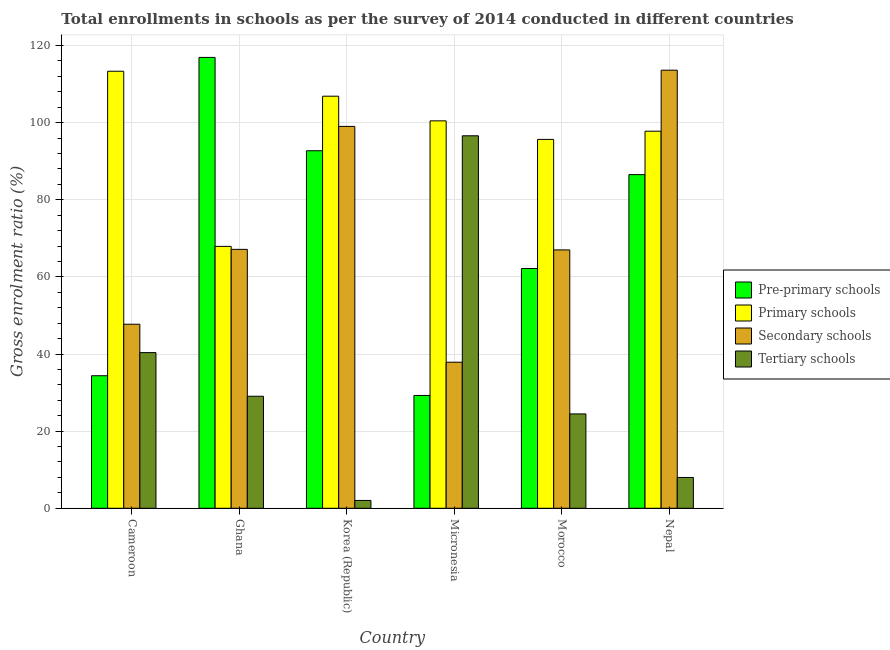How many different coloured bars are there?
Give a very brief answer. 4. Are the number of bars on each tick of the X-axis equal?
Give a very brief answer. Yes. What is the label of the 1st group of bars from the left?
Make the answer very short. Cameroon. In how many cases, is the number of bars for a given country not equal to the number of legend labels?
Keep it short and to the point. 0. What is the gross enrolment ratio in secondary schools in Ghana?
Make the answer very short. 67.13. Across all countries, what is the maximum gross enrolment ratio in tertiary schools?
Provide a short and direct response. 96.58. Across all countries, what is the minimum gross enrolment ratio in secondary schools?
Make the answer very short. 37.87. In which country was the gross enrolment ratio in secondary schools maximum?
Keep it short and to the point. Nepal. What is the total gross enrolment ratio in tertiary schools in the graph?
Provide a succinct answer. 200.48. What is the difference between the gross enrolment ratio in secondary schools in Cameroon and that in Morocco?
Your response must be concise. -19.27. What is the difference between the gross enrolment ratio in primary schools in Cameroon and the gross enrolment ratio in pre-primary schools in Morocco?
Your answer should be compact. 51.15. What is the average gross enrolment ratio in secondary schools per country?
Keep it short and to the point. 72.06. What is the difference between the gross enrolment ratio in secondary schools and gross enrolment ratio in tertiary schools in Micronesia?
Offer a very short reply. -58.71. In how many countries, is the gross enrolment ratio in tertiary schools greater than 116 %?
Give a very brief answer. 0. What is the ratio of the gross enrolment ratio in tertiary schools in Cameroon to that in Ghana?
Make the answer very short. 1.39. What is the difference between the highest and the second highest gross enrolment ratio in pre-primary schools?
Offer a terse response. 24.2. What is the difference between the highest and the lowest gross enrolment ratio in primary schools?
Your response must be concise. 45.42. In how many countries, is the gross enrolment ratio in primary schools greater than the average gross enrolment ratio in primary schools taken over all countries?
Make the answer very short. 4. Is the sum of the gross enrolment ratio in secondary schools in Micronesia and Nepal greater than the maximum gross enrolment ratio in pre-primary schools across all countries?
Provide a short and direct response. Yes. Is it the case that in every country, the sum of the gross enrolment ratio in pre-primary schools and gross enrolment ratio in primary schools is greater than the sum of gross enrolment ratio in secondary schools and gross enrolment ratio in tertiary schools?
Make the answer very short. No. What does the 4th bar from the left in Morocco represents?
Your answer should be very brief. Tertiary schools. What does the 4th bar from the right in Cameroon represents?
Provide a succinct answer. Pre-primary schools. What is the difference between two consecutive major ticks on the Y-axis?
Provide a short and direct response. 20. Does the graph contain any zero values?
Offer a very short reply. No. What is the title of the graph?
Keep it short and to the point. Total enrollments in schools as per the survey of 2014 conducted in different countries. What is the label or title of the X-axis?
Ensure brevity in your answer.  Country. What is the label or title of the Y-axis?
Offer a very short reply. Gross enrolment ratio (%). What is the Gross enrolment ratio (%) of Pre-primary schools in Cameroon?
Provide a succinct answer. 34.37. What is the Gross enrolment ratio (%) in Primary schools in Cameroon?
Make the answer very short. 113.32. What is the Gross enrolment ratio (%) in Secondary schools in Cameroon?
Give a very brief answer. 47.72. What is the Gross enrolment ratio (%) of Tertiary schools in Cameroon?
Make the answer very short. 40.36. What is the Gross enrolment ratio (%) of Pre-primary schools in Ghana?
Provide a short and direct response. 116.91. What is the Gross enrolment ratio (%) in Primary schools in Ghana?
Your response must be concise. 67.91. What is the Gross enrolment ratio (%) in Secondary schools in Ghana?
Provide a succinct answer. 67.13. What is the Gross enrolment ratio (%) of Tertiary schools in Ghana?
Provide a succinct answer. 29.05. What is the Gross enrolment ratio (%) of Pre-primary schools in Korea (Republic)?
Provide a short and direct response. 92.71. What is the Gross enrolment ratio (%) in Primary schools in Korea (Republic)?
Ensure brevity in your answer.  106.85. What is the Gross enrolment ratio (%) in Secondary schools in Korea (Republic)?
Provide a short and direct response. 99.02. What is the Gross enrolment ratio (%) in Tertiary schools in Korea (Republic)?
Provide a succinct answer. 2.03. What is the Gross enrolment ratio (%) of Pre-primary schools in Micronesia?
Keep it short and to the point. 29.25. What is the Gross enrolment ratio (%) of Primary schools in Micronesia?
Keep it short and to the point. 100.46. What is the Gross enrolment ratio (%) in Secondary schools in Micronesia?
Give a very brief answer. 37.87. What is the Gross enrolment ratio (%) of Tertiary schools in Micronesia?
Provide a succinct answer. 96.58. What is the Gross enrolment ratio (%) in Pre-primary schools in Morocco?
Make the answer very short. 62.17. What is the Gross enrolment ratio (%) of Primary schools in Morocco?
Offer a very short reply. 95.65. What is the Gross enrolment ratio (%) of Secondary schools in Morocco?
Give a very brief answer. 66.99. What is the Gross enrolment ratio (%) in Tertiary schools in Morocco?
Offer a very short reply. 24.47. What is the Gross enrolment ratio (%) in Pre-primary schools in Nepal?
Ensure brevity in your answer.  86.52. What is the Gross enrolment ratio (%) of Primary schools in Nepal?
Provide a succinct answer. 97.77. What is the Gross enrolment ratio (%) of Secondary schools in Nepal?
Keep it short and to the point. 113.6. What is the Gross enrolment ratio (%) in Tertiary schools in Nepal?
Provide a succinct answer. 7.99. Across all countries, what is the maximum Gross enrolment ratio (%) of Pre-primary schools?
Keep it short and to the point. 116.91. Across all countries, what is the maximum Gross enrolment ratio (%) in Primary schools?
Make the answer very short. 113.32. Across all countries, what is the maximum Gross enrolment ratio (%) in Secondary schools?
Keep it short and to the point. 113.6. Across all countries, what is the maximum Gross enrolment ratio (%) of Tertiary schools?
Keep it short and to the point. 96.58. Across all countries, what is the minimum Gross enrolment ratio (%) of Pre-primary schools?
Give a very brief answer. 29.25. Across all countries, what is the minimum Gross enrolment ratio (%) in Primary schools?
Offer a very short reply. 67.91. Across all countries, what is the minimum Gross enrolment ratio (%) in Secondary schools?
Ensure brevity in your answer.  37.87. Across all countries, what is the minimum Gross enrolment ratio (%) in Tertiary schools?
Provide a short and direct response. 2.03. What is the total Gross enrolment ratio (%) of Pre-primary schools in the graph?
Provide a short and direct response. 421.93. What is the total Gross enrolment ratio (%) in Primary schools in the graph?
Offer a terse response. 581.96. What is the total Gross enrolment ratio (%) in Secondary schools in the graph?
Offer a very short reply. 432.34. What is the total Gross enrolment ratio (%) in Tertiary schools in the graph?
Your answer should be compact. 200.48. What is the difference between the Gross enrolment ratio (%) of Pre-primary schools in Cameroon and that in Ghana?
Keep it short and to the point. -82.54. What is the difference between the Gross enrolment ratio (%) in Primary schools in Cameroon and that in Ghana?
Make the answer very short. 45.42. What is the difference between the Gross enrolment ratio (%) of Secondary schools in Cameroon and that in Ghana?
Provide a succinct answer. -19.41. What is the difference between the Gross enrolment ratio (%) of Tertiary schools in Cameroon and that in Ghana?
Your answer should be very brief. 11.32. What is the difference between the Gross enrolment ratio (%) of Pre-primary schools in Cameroon and that in Korea (Republic)?
Ensure brevity in your answer.  -58.34. What is the difference between the Gross enrolment ratio (%) of Primary schools in Cameroon and that in Korea (Republic)?
Give a very brief answer. 6.47. What is the difference between the Gross enrolment ratio (%) of Secondary schools in Cameroon and that in Korea (Republic)?
Give a very brief answer. -51.3. What is the difference between the Gross enrolment ratio (%) in Tertiary schools in Cameroon and that in Korea (Republic)?
Offer a very short reply. 38.33. What is the difference between the Gross enrolment ratio (%) in Pre-primary schools in Cameroon and that in Micronesia?
Offer a terse response. 5.12. What is the difference between the Gross enrolment ratio (%) of Primary schools in Cameroon and that in Micronesia?
Your answer should be compact. 12.87. What is the difference between the Gross enrolment ratio (%) of Secondary schools in Cameroon and that in Micronesia?
Keep it short and to the point. 9.85. What is the difference between the Gross enrolment ratio (%) in Tertiary schools in Cameroon and that in Micronesia?
Provide a short and direct response. -56.22. What is the difference between the Gross enrolment ratio (%) of Pre-primary schools in Cameroon and that in Morocco?
Ensure brevity in your answer.  -27.8. What is the difference between the Gross enrolment ratio (%) in Primary schools in Cameroon and that in Morocco?
Make the answer very short. 17.67. What is the difference between the Gross enrolment ratio (%) of Secondary schools in Cameroon and that in Morocco?
Offer a very short reply. -19.27. What is the difference between the Gross enrolment ratio (%) of Tertiary schools in Cameroon and that in Morocco?
Your answer should be compact. 15.89. What is the difference between the Gross enrolment ratio (%) of Pre-primary schools in Cameroon and that in Nepal?
Your answer should be compact. -52.15. What is the difference between the Gross enrolment ratio (%) of Primary schools in Cameroon and that in Nepal?
Offer a terse response. 15.55. What is the difference between the Gross enrolment ratio (%) of Secondary schools in Cameroon and that in Nepal?
Your response must be concise. -65.88. What is the difference between the Gross enrolment ratio (%) of Tertiary schools in Cameroon and that in Nepal?
Make the answer very short. 32.37. What is the difference between the Gross enrolment ratio (%) of Pre-primary schools in Ghana and that in Korea (Republic)?
Offer a terse response. 24.2. What is the difference between the Gross enrolment ratio (%) of Primary schools in Ghana and that in Korea (Republic)?
Your answer should be compact. -38.95. What is the difference between the Gross enrolment ratio (%) in Secondary schools in Ghana and that in Korea (Republic)?
Ensure brevity in your answer.  -31.89. What is the difference between the Gross enrolment ratio (%) of Tertiary schools in Ghana and that in Korea (Republic)?
Your response must be concise. 27.02. What is the difference between the Gross enrolment ratio (%) in Pre-primary schools in Ghana and that in Micronesia?
Provide a succinct answer. 87.65. What is the difference between the Gross enrolment ratio (%) of Primary schools in Ghana and that in Micronesia?
Your answer should be compact. -32.55. What is the difference between the Gross enrolment ratio (%) in Secondary schools in Ghana and that in Micronesia?
Offer a terse response. 29.26. What is the difference between the Gross enrolment ratio (%) of Tertiary schools in Ghana and that in Micronesia?
Ensure brevity in your answer.  -67.54. What is the difference between the Gross enrolment ratio (%) of Pre-primary schools in Ghana and that in Morocco?
Provide a succinct answer. 54.73. What is the difference between the Gross enrolment ratio (%) of Primary schools in Ghana and that in Morocco?
Your answer should be very brief. -27.74. What is the difference between the Gross enrolment ratio (%) of Secondary schools in Ghana and that in Morocco?
Provide a succinct answer. 0.14. What is the difference between the Gross enrolment ratio (%) in Tertiary schools in Ghana and that in Morocco?
Your response must be concise. 4.58. What is the difference between the Gross enrolment ratio (%) of Pre-primary schools in Ghana and that in Nepal?
Offer a very short reply. 30.39. What is the difference between the Gross enrolment ratio (%) of Primary schools in Ghana and that in Nepal?
Provide a succinct answer. -29.87. What is the difference between the Gross enrolment ratio (%) in Secondary schools in Ghana and that in Nepal?
Provide a short and direct response. -46.46. What is the difference between the Gross enrolment ratio (%) in Tertiary schools in Ghana and that in Nepal?
Offer a very short reply. 21.06. What is the difference between the Gross enrolment ratio (%) of Pre-primary schools in Korea (Republic) and that in Micronesia?
Provide a short and direct response. 63.45. What is the difference between the Gross enrolment ratio (%) of Primary schools in Korea (Republic) and that in Micronesia?
Offer a very short reply. 6.4. What is the difference between the Gross enrolment ratio (%) of Secondary schools in Korea (Republic) and that in Micronesia?
Your answer should be compact. 61.15. What is the difference between the Gross enrolment ratio (%) in Tertiary schools in Korea (Republic) and that in Micronesia?
Provide a short and direct response. -94.55. What is the difference between the Gross enrolment ratio (%) of Pre-primary schools in Korea (Republic) and that in Morocco?
Give a very brief answer. 30.53. What is the difference between the Gross enrolment ratio (%) in Primary schools in Korea (Republic) and that in Morocco?
Your answer should be very brief. 11.2. What is the difference between the Gross enrolment ratio (%) of Secondary schools in Korea (Republic) and that in Morocco?
Ensure brevity in your answer.  32.03. What is the difference between the Gross enrolment ratio (%) in Tertiary schools in Korea (Republic) and that in Morocco?
Your response must be concise. -22.44. What is the difference between the Gross enrolment ratio (%) of Pre-primary schools in Korea (Republic) and that in Nepal?
Provide a succinct answer. 6.19. What is the difference between the Gross enrolment ratio (%) of Primary schools in Korea (Republic) and that in Nepal?
Make the answer very short. 9.08. What is the difference between the Gross enrolment ratio (%) in Secondary schools in Korea (Republic) and that in Nepal?
Make the answer very short. -14.58. What is the difference between the Gross enrolment ratio (%) in Tertiary schools in Korea (Republic) and that in Nepal?
Provide a short and direct response. -5.96. What is the difference between the Gross enrolment ratio (%) of Pre-primary schools in Micronesia and that in Morocco?
Provide a short and direct response. -32.92. What is the difference between the Gross enrolment ratio (%) of Primary schools in Micronesia and that in Morocco?
Make the answer very short. 4.81. What is the difference between the Gross enrolment ratio (%) of Secondary schools in Micronesia and that in Morocco?
Your answer should be very brief. -29.12. What is the difference between the Gross enrolment ratio (%) of Tertiary schools in Micronesia and that in Morocco?
Your answer should be very brief. 72.12. What is the difference between the Gross enrolment ratio (%) of Pre-primary schools in Micronesia and that in Nepal?
Your answer should be compact. -57.26. What is the difference between the Gross enrolment ratio (%) of Primary schools in Micronesia and that in Nepal?
Make the answer very short. 2.68. What is the difference between the Gross enrolment ratio (%) in Secondary schools in Micronesia and that in Nepal?
Your response must be concise. -75.72. What is the difference between the Gross enrolment ratio (%) in Tertiary schools in Micronesia and that in Nepal?
Your answer should be very brief. 88.6. What is the difference between the Gross enrolment ratio (%) of Pre-primary schools in Morocco and that in Nepal?
Keep it short and to the point. -24.34. What is the difference between the Gross enrolment ratio (%) of Primary schools in Morocco and that in Nepal?
Provide a succinct answer. -2.12. What is the difference between the Gross enrolment ratio (%) in Secondary schools in Morocco and that in Nepal?
Your answer should be very brief. -46.61. What is the difference between the Gross enrolment ratio (%) of Tertiary schools in Morocco and that in Nepal?
Your response must be concise. 16.48. What is the difference between the Gross enrolment ratio (%) in Pre-primary schools in Cameroon and the Gross enrolment ratio (%) in Primary schools in Ghana?
Offer a terse response. -33.54. What is the difference between the Gross enrolment ratio (%) of Pre-primary schools in Cameroon and the Gross enrolment ratio (%) of Secondary schools in Ghana?
Keep it short and to the point. -32.76. What is the difference between the Gross enrolment ratio (%) in Pre-primary schools in Cameroon and the Gross enrolment ratio (%) in Tertiary schools in Ghana?
Ensure brevity in your answer.  5.32. What is the difference between the Gross enrolment ratio (%) in Primary schools in Cameroon and the Gross enrolment ratio (%) in Secondary schools in Ghana?
Keep it short and to the point. 46.19. What is the difference between the Gross enrolment ratio (%) in Primary schools in Cameroon and the Gross enrolment ratio (%) in Tertiary schools in Ghana?
Offer a very short reply. 84.28. What is the difference between the Gross enrolment ratio (%) of Secondary schools in Cameroon and the Gross enrolment ratio (%) of Tertiary schools in Ghana?
Offer a terse response. 18.68. What is the difference between the Gross enrolment ratio (%) of Pre-primary schools in Cameroon and the Gross enrolment ratio (%) of Primary schools in Korea (Republic)?
Your answer should be compact. -72.48. What is the difference between the Gross enrolment ratio (%) in Pre-primary schools in Cameroon and the Gross enrolment ratio (%) in Secondary schools in Korea (Republic)?
Your answer should be very brief. -64.65. What is the difference between the Gross enrolment ratio (%) of Pre-primary schools in Cameroon and the Gross enrolment ratio (%) of Tertiary schools in Korea (Republic)?
Your response must be concise. 32.34. What is the difference between the Gross enrolment ratio (%) in Primary schools in Cameroon and the Gross enrolment ratio (%) in Secondary schools in Korea (Republic)?
Your answer should be very brief. 14.3. What is the difference between the Gross enrolment ratio (%) of Primary schools in Cameroon and the Gross enrolment ratio (%) of Tertiary schools in Korea (Republic)?
Make the answer very short. 111.29. What is the difference between the Gross enrolment ratio (%) of Secondary schools in Cameroon and the Gross enrolment ratio (%) of Tertiary schools in Korea (Republic)?
Provide a succinct answer. 45.69. What is the difference between the Gross enrolment ratio (%) in Pre-primary schools in Cameroon and the Gross enrolment ratio (%) in Primary schools in Micronesia?
Your answer should be very brief. -66.09. What is the difference between the Gross enrolment ratio (%) of Pre-primary schools in Cameroon and the Gross enrolment ratio (%) of Secondary schools in Micronesia?
Make the answer very short. -3.5. What is the difference between the Gross enrolment ratio (%) in Pre-primary schools in Cameroon and the Gross enrolment ratio (%) in Tertiary schools in Micronesia?
Your answer should be very brief. -62.22. What is the difference between the Gross enrolment ratio (%) in Primary schools in Cameroon and the Gross enrolment ratio (%) in Secondary schools in Micronesia?
Your answer should be very brief. 75.45. What is the difference between the Gross enrolment ratio (%) of Primary schools in Cameroon and the Gross enrolment ratio (%) of Tertiary schools in Micronesia?
Offer a terse response. 16.74. What is the difference between the Gross enrolment ratio (%) in Secondary schools in Cameroon and the Gross enrolment ratio (%) in Tertiary schools in Micronesia?
Offer a terse response. -48.86. What is the difference between the Gross enrolment ratio (%) in Pre-primary schools in Cameroon and the Gross enrolment ratio (%) in Primary schools in Morocco?
Offer a terse response. -61.28. What is the difference between the Gross enrolment ratio (%) in Pre-primary schools in Cameroon and the Gross enrolment ratio (%) in Secondary schools in Morocco?
Keep it short and to the point. -32.62. What is the difference between the Gross enrolment ratio (%) of Pre-primary schools in Cameroon and the Gross enrolment ratio (%) of Tertiary schools in Morocco?
Offer a terse response. 9.9. What is the difference between the Gross enrolment ratio (%) in Primary schools in Cameroon and the Gross enrolment ratio (%) in Secondary schools in Morocco?
Your answer should be very brief. 46.33. What is the difference between the Gross enrolment ratio (%) in Primary schools in Cameroon and the Gross enrolment ratio (%) in Tertiary schools in Morocco?
Your response must be concise. 88.85. What is the difference between the Gross enrolment ratio (%) of Secondary schools in Cameroon and the Gross enrolment ratio (%) of Tertiary schools in Morocco?
Make the answer very short. 23.25. What is the difference between the Gross enrolment ratio (%) in Pre-primary schools in Cameroon and the Gross enrolment ratio (%) in Primary schools in Nepal?
Provide a short and direct response. -63.4. What is the difference between the Gross enrolment ratio (%) of Pre-primary schools in Cameroon and the Gross enrolment ratio (%) of Secondary schools in Nepal?
Ensure brevity in your answer.  -79.23. What is the difference between the Gross enrolment ratio (%) of Pre-primary schools in Cameroon and the Gross enrolment ratio (%) of Tertiary schools in Nepal?
Offer a very short reply. 26.38. What is the difference between the Gross enrolment ratio (%) of Primary schools in Cameroon and the Gross enrolment ratio (%) of Secondary schools in Nepal?
Ensure brevity in your answer.  -0.28. What is the difference between the Gross enrolment ratio (%) in Primary schools in Cameroon and the Gross enrolment ratio (%) in Tertiary schools in Nepal?
Your response must be concise. 105.33. What is the difference between the Gross enrolment ratio (%) in Secondary schools in Cameroon and the Gross enrolment ratio (%) in Tertiary schools in Nepal?
Your answer should be compact. 39.73. What is the difference between the Gross enrolment ratio (%) of Pre-primary schools in Ghana and the Gross enrolment ratio (%) of Primary schools in Korea (Republic)?
Offer a very short reply. 10.05. What is the difference between the Gross enrolment ratio (%) of Pre-primary schools in Ghana and the Gross enrolment ratio (%) of Secondary schools in Korea (Republic)?
Your answer should be compact. 17.89. What is the difference between the Gross enrolment ratio (%) of Pre-primary schools in Ghana and the Gross enrolment ratio (%) of Tertiary schools in Korea (Republic)?
Give a very brief answer. 114.88. What is the difference between the Gross enrolment ratio (%) in Primary schools in Ghana and the Gross enrolment ratio (%) in Secondary schools in Korea (Republic)?
Ensure brevity in your answer.  -31.11. What is the difference between the Gross enrolment ratio (%) in Primary schools in Ghana and the Gross enrolment ratio (%) in Tertiary schools in Korea (Republic)?
Offer a terse response. 65.88. What is the difference between the Gross enrolment ratio (%) of Secondary schools in Ghana and the Gross enrolment ratio (%) of Tertiary schools in Korea (Republic)?
Keep it short and to the point. 65.1. What is the difference between the Gross enrolment ratio (%) of Pre-primary schools in Ghana and the Gross enrolment ratio (%) of Primary schools in Micronesia?
Your answer should be very brief. 16.45. What is the difference between the Gross enrolment ratio (%) of Pre-primary schools in Ghana and the Gross enrolment ratio (%) of Secondary schools in Micronesia?
Provide a succinct answer. 79.03. What is the difference between the Gross enrolment ratio (%) of Pre-primary schools in Ghana and the Gross enrolment ratio (%) of Tertiary schools in Micronesia?
Ensure brevity in your answer.  20.32. What is the difference between the Gross enrolment ratio (%) in Primary schools in Ghana and the Gross enrolment ratio (%) in Secondary schools in Micronesia?
Ensure brevity in your answer.  30.03. What is the difference between the Gross enrolment ratio (%) of Primary schools in Ghana and the Gross enrolment ratio (%) of Tertiary schools in Micronesia?
Give a very brief answer. -28.68. What is the difference between the Gross enrolment ratio (%) in Secondary schools in Ghana and the Gross enrolment ratio (%) in Tertiary schools in Micronesia?
Provide a short and direct response. -29.45. What is the difference between the Gross enrolment ratio (%) of Pre-primary schools in Ghana and the Gross enrolment ratio (%) of Primary schools in Morocco?
Offer a very short reply. 21.26. What is the difference between the Gross enrolment ratio (%) of Pre-primary schools in Ghana and the Gross enrolment ratio (%) of Secondary schools in Morocco?
Offer a very short reply. 49.91. What is the difference between the Gross enrolment ratio (%) of Pre-primary schools in Ghana and the Gross enrolment ratio (%) of Tertiary schools in Morocco?
Your answer should be compact. 92.44. What is the difference between the Gross enrolment ratio (%) of Primary schools in Ghana and the Gross enrolment ratio (%) of Secondary schools in Morocco?
Give a very brief answer. 0.91. What is the difference between the Gross enrolment ratio (%) of Primary schools in Ghana and the Gross enrolment ratio (%) of Tertiary schools in Morocco?
Offer a very short reply. 43.44. What is the difference between the Gross enrolment ratio (%) in Secondary schools in Ghana and the Gross enrolment ratio (%) in Tertiary schools in Morocco?
Your answer should be compact. 42.67. What is the difference between the Gross enrolment ratio (%) in Pre-primary schools in Ghana and the Gross enrolment ratio (%) in Primary schools in Nepal?
Offer a terse response. 19.13. What is the difference between the Gross enrolment ratio (%) in Pre-primary schools in Ghana and the Gross enrolment ratio (%) in Secondary schools in Nepal?
Your answer should be very brief. 3.31. What is the difference between the Gross enrolment ratio (%) of Pre-primary schools in Ghana and the Gross enrolment ratio (%) of Tertiary schools in Nepal?
Give a very brief answer. 108.92. What is the difference between the Gross enrolment ratio (%) in Primary schools in Ghana and the Gross enrolment ratio (%) in Secondary schools in Nepal?
Your answer should be compact. -45.69. What is the difference between the Gross enrolment ratio (%) in Primary schools in Ghana and the Gross enrolment ratio (%) in Tertiary schools in Nepal?
Ensure brevity in your answer.  59.92. What is the difference between the Gross enrolment ratio (%) of Secondary schools in Ghana and the Gross enrolment ratio (%) of Tertiary schools in Nepal?
Keep it short and to the point. 59.15. What is the difference between the Gross enrolment ratio (%) in Pre-primary schools in Korea (Republic) and the Gross enrolment ratio (%) in Primary schools in Micronesia?
Offer a very short reply. -7.75. What is the difference between the Gross enrolment ratio (%) of Pre-primary schools in Korea (Republic) and the Gross enrolment ratio (%) of Secondary schools in Micronesia?
Keep it short and to the point. 54.83. What is the difference between the Gross enrolment ratio (%) of Pre-primary schools in Korea (Republic) and the Gross enrolment ratio (%) of Tertiary schools in Micronesia?
Your response must be concise. -3.88. What is the difference between the Gross enrolment ratio (%) of Primary schools in Korea (Republic) and the Gross enrolment ratio (%) of Secondary schools in Micronesia?
Make the answer very short. 68.98. What is the difference between the Gross enrolment ratio (%) in Primary schools in Korea (Republic) and the Gross enrolment ratio (%) in Tertiary schools in Micronesia?
Provide a short and direct response. 10.27. What is the difference between the Gross enrolment ratio (%) in Secondary schools in Korea (Republic) and the Gross enrolment ratio (%) in Tertiary schools in Micronesia?
Ensure brevity in your answer.  2.43. What is the difference between the Gross enrolment ratio (%) in Pre-primary schools in Korea (Republic) and the Gross enrolment ratio (%) in Primary schools in Morocco?
Keep it short and to the point. -2.94. What is the difference between the Gross enrolment ratio (%) in Pre-primary schools in Korea (Republic) and the Gross enrolment ratio (%) in Secondary schools in Morocco?
Offer a terse response. 25.71. What is the difference between the Gross enrolment ratio (%) of Pre-primary schools in Korea (Republic) and the Gross enrolment ratio (%) of Tertiary schools in Morocco?
Provide a short and direct response. 68.24. What is the difference between the Gross enrolment ratio (%) in Primary schools in Korea (Republic) and the Gross enrolment ratio (%) in Secondary schools in Morocco?
Provide a succinct answer. 39.86. What is the difference between the Gross enrolment ratio (%) in Primary schools in Korea (Republic) and the Gross enrolment ratio (%) in Tertiary schools in Morocco?
Your response must be concise. 82.38. What is the difference between the Gross enrolment ratio (%) in Secondary schools in Korea (Republic) and the Gross enrolment ratio (%) in Tertiary schools in Morocco?
Provide a short and direct response. 74.55. What is the difference between the Gross enrolment ratio (%) in Pre-primary schools in Korea (Republic) and the Gross enrolment ratio (%) in Primary schools in Nepal?
Your response must be concise. -5.07. What is the difference between the Gross enrolment ratio (%) in Pre-primary schools in Korea (Republic) and the Gross enrolment ratio (%) in Secondary schools in Nepal?
Ensure brevity in your answer.  -20.89. What is the difference between the Gross enrolment ratio (%) in Pre-primary schools in Korea (Republic) and the Gross enrolment ratio (%) in Tertiary schools in Nepal?
Offer a terse response. 84.72. What is the difference between the Gross enrolment ratio (%) of Primary schools in Korea (Republic) and the Gross enrolment ratio (%) of Secondary schools in Nepal?
Provide a short and direct response. -6.74. What is the difference between the Gross enrolment ratio (%) of Primary schools in Korea (Republic) and the Gross enrolment ratio (%) of Tertiary schools in Nepal?
Your answer should be very brief. 98.87. What is the difference between the Gross enrolment ratio (%) in Secondary schools in Korea (Republic) and the Gross enrolment ratio (%) in Tertiary schools in Nepal?
Make the answer very short. 91.03. What is the difference between the Gross enrolment ratio (%) of Pre-primary schools in Micronesia and the Gross enrolment ratio (%) of Primary schools in Morocco?
Ensure brevity in your answer.  -66.4. What is the difference between the Gross enrolment ratio (%) in Pre-primary schools in Micronesia and the Gross enrolment ratio (%) in Secondary schools in Morocco?
Your response must be concise. -37.74. What is the difference between the Gross enrolment ratio (%) in Pre-primary schools in Micronesia and the Gross enrolment ratio (%) in Tertiary schools in Morocco?
Make the answer very short. 4.79. What is the difference between the Gross enrolment ratio (%) of Primary schools in Micronesia and the Gross enrolment ratio (%) of Secondary schools in Morocco?
Your answer should be compact. 33.46. What is the difference between the Gross enrolment ratio (%) in Primary schools in Micronesia and the Gross enrolment ratio (%) in Tertiary schools in Morocco?
Offer a very short reply. 75.99. What is the difference between the Gross enrolment ratio (%) in Secondary schools in Micronesia and the Gross enrolment ratio (%) in Tertiary schools in Morocco?
Your answer should be very brief. 13.41. What is the difference between the Gross enrolment ratio (%) of Pre-primary schools in Micronesia and the Gross enrolment ratio (%) of Primary schools in Nepal?
Your answer should be very brief. -68.52. What is the difference between the Gross enrolment ratio (%) of Pre-primary schools in Micronesia and the Gross enrolment ratio (%) of Secondary schools in Nepal?
Your answer should be very brief. -84.34. What is the difference between the Gross enrolment ratio (%) in Pre-primary schools in Micronesia and the Gross enrolment ratio (%) in Tertiary schools in Nepal?
Provide a succinct answer. 21.27. What is the difference between the Gross enrolment ratio (%) of Primary schools in Micronesia and the Gross enrolment ratio (%) of Secondary schools in Nepal?
Provide a succinct answer. -13.14. What is the difference between the Gross enrolment ratio (%) of Primary schools in Micronesia and the Gross enrolment ratio (%) of Tertiary schools in Nepal?
Your answer should be compact. 92.47. What is the difference between the Gross enrolment ratio (%) of Secondary schools in Micronesia and the Gross enrolment ratio (%) of Tertiary schools in Nepal?
Your answer should be compact. 29.89. What is the difference between the Gross enrolment ratio (%) in Pre-primary schools in Morocco and the Gross enrolment ratio (%) in Primary schools in Nepal?
Ensure brevity in your answer.  -35.6. What is the difference between the Gross enrolment ratio (%) in Pre-primary schools in Morocco and the Gross enrolment ratio (%) in Secondary schools in Nepal?
Ensure brevity in your answer.  -51.42. What is the difference between the Gross enrolment ratio (%) of Pre-primary schools in Morocco and the Gross enrolment ratio (%) of Tertiary schools in Nepal?
Keep it short and to the point. 54.19. What is the difference between the Gross enrolment ratio (%) of Primary schools in Morocco and the Gross enrolment ratio (%) of Secondary schools in Nepal?
Offer a very short reply. -17.95. What is the difference between the Gross enrolment ratio (%) in Primary schools in Morocco and the Gross enrolment ratio (%) in Tertiary schools in Nepal?
Make the answer very short. 87.66. What is the difference between the Gross enrolment ratio (%) in Secondary schools in Morocco and the Gross enrolment ratio (%) in Tertiary schools in Nepal?
Give a very brief answer. 59. What is the average Gross enrolment ratio (%) in Pre-primary schools per country?
Your answer should be very brief. 70.32. What is the average Gross enrolment ratio (%) in Primary schools per country?
Ensure brevity in your answer.  96.99. What is the average Gross enrolment ratio (%) of Secondary schools per country?
Offer a terse response. 72.06. What is the average Gross enrolment ratio (%) in Tertiary schools per country?
Your answer should be compact. 33.41. What is the difference between the Gross enrolment ratio (%) in Pre-primary schools and Gross enrolment ratio (%) in Primary schools in Cameroon?
Keep it short and to the point. -78.95. What is the difference between the Gross enrolment ratio (%) of Pre-primary schools and Gross enrolment ratio (%) of Secondary schools in Cameroon?
Offer a terse response. -13.35. What is the difference between the Gross enrolment ratio (%) in Pre-primary schools and Gross enrolment ratio (%) in Tertiary schools in Cameroon?
Keep it short and to the point. -5.99. What is the difference between the Gross enrolment ratio (%) of Primary schools and Gross enrolment ratio (%) of Secondary schools in Cameroon?
Provide a succinct answer. 65.6. What is the difference between the Gross enrolment ratio (%) in Primary schools and Gross enrolment ratio (%) in Tertiary schools in Cameroon?
Make the answer very short. 72.96. What is the difference between the Gross enrolment ratio (%) in Secondary schools and Gross enrolment ratio (%) in Tertiary schools in Cameroon?
Provide a short and direct response. 7.36. What is the difference between the Gross enrolment ratio (%) in Pre-primary schools and Gross enrolment ratio (%) in Primary schools in Ghana?
Provide a short and direct response. 49. What is the difference between the Gross enrolment ratio (%) of Pre-primary schools and Gross enrolment ratio (%) of Secondary schools in Ghana?
Provide a succinct answer. 49.77. What is the difference between the Gross enrolment ratio (%) of Pre-primary schools and Gross enrolment ratio (%) of Tertiary schools in Ghana?
Your response must be concise. 87.86. What is the difference between the Gross enrolment ratio (%) of Primary schools and Gross enrolment ratio (%) of Secondary schools in Ghana?
Keep it short and to the point. 0.77. What is the difference between the Gross enrolment ratio (%) of Primary schools and Gross enrolment ratio (%) of Tertiary schools in Ghana?
Your answer should be compact. 38.86. What is the difference between the Gross enrolment ratio (%) of Secondary schools and Gross enrolment ratio (%) of Tertiary schools in Ghana?
Offer a very short reply. 38.09. What is the difference between the Gross enrolment ratio (%) in Pre-primary schools and Gross enrolment ratio (%) in Primary schools in Korea (Republic)?
Your answer should be compact. -14.15. What is the difference between the Gross enrolment ratio (%) of Pre-primary schools and Gross enrolment ratio (%) of Secondary schools in Korea (Republic)?
Your answer should be compact. -6.31. What is the difference between the Gross enrolment ratio (%) of Pre-primary schools and Gross enrolment ratio (%) of Tertiary schools in Korea (Republic)?
Offer a terse response. 90.68. What is the difference between the Gross enrolment ratio (%) in Primary schools and Gross enrolment ratio (%) in Secondary schools in Korea (Republic)?
Your answer should be compact. 7.83. What is the difference between the Gross enrolment ratio (%) in Primary schools and Gross enrolment ratio (%) in Tertiary schools in Korea (Republic)?
Your answer should be very brief. 104.82. What is the difference between the Gross enrolment ratio (%) of Secondary schools and Gross enrolment ratio (%) of Tertiary schools in Korea (Republic)?
Give a very brief answer. 96.99. What is the difference between the Gross enrolment ratio (%) in Pre-primary schools and Gross enrolment ratio (%) in Primary schools in Micronesia?
Your answer should be compact. -71.2. What is the difference between the Gross enrolment ratio (%) of Pre-primary schools and Gross enrolment ratio (%) of Secondary schools in Micronesia?
Offer a terse response. -8.62. What is the difference between the Gross enrolment ratio (%) of Pre-primary schools and Gross enrolment ratio (%) of Tertiary schools in Micronesia?
Provide a short and direct response. -67.33. What is the difference between the Gross enrolment ratio (%) of Primary schools and Gross enrolment ratio (%) of Secondary schools in Micronesia?
Your answer should be compact. 62.58. What is the difference between the Gross enrolment ratio (%) of Primary schools and Gross enrolment ratio (%) of Tertiary schools in Micronesia?
Make the answer very short. 3.87. What is the difference between the Gross enrolment ratio (%) of Secondary schools and Gross enrolment ratio (%) of Tertiary schools in Micronesia?
Offer a terse response. -58.71. What is the difference between the Gross enrolment ratio (%) of Pre-primary schools and Gross enrolment ratio (%) of Primary schools in Morocco?
Offer a very short reply. -33.48. What is the difference between the Gross enrolment ratio (%) in Pre-primary schools and Gross enrolment ratio (%) in Secondary schools in Morocco?
Make the answer very short. -4.82. What is the difference between the Gross enrolment ratio (%) in Pre-primary schools and Gross enrolment ratio (%) in Tertiary schools in Morocco?
Your response must be concise. 37.71. What is the difference between the Gross enrolment ratio (%) in Primary schools and Gross enrolment ratio (%) in Secondary schools in Morocco?
Give a very brief answer. 28.66. What is the difference between the Gross enrolment ratio (%) of Primary schools and Gross enrolment ratio (%) of Tertiary schools in Morocco?
Keep it short and to the point. 71.18. What is the difference between the Gross enrolment ratio (%) in Secondary schools and Gross enrolment ratio (%) in Tertiary schools in Morocco?
Make the answer very short. 42.52. What is the difference between the Gross enrolment ratio (%) of Pre-primary schools and Gross enrolment ratio (%) of Primary schools in Nepal?
Offer a terse response. -11.25. What is the difference between the Gross enrolment ratio (%) of Pre-primary schools and Gross enrolment ratio (%) of Secondary schools in Nepal?
Give a very brief answer. -27.08. What is the difference between the Gross enrolment ratio (%) of Pre-primary schools and Gross enrolment ratio (%) of Tertiary schools in Nepal?
Make the answer very short. 78.53. What is the difference between the Gross enrolment ratio (%) in Primary schools and Gross enrolment ratio (%) in Secondary schools in Nepal?
Provide a short and direct response. -15.83. What is the difference between the Gross enrolment ratio (%) of Primary schools and Gross enrolment ratio (%) of Tertiary schools in Nepal?
Provide a succinct answer. 89.78. What is the difference between the Gross enrolment ratio (%) of Secondary schools and Gross enrolment ratio (%) of Tertiary schools in Nepal?
Your response must be concise. 105.61. What is the ratio of the Gross enrolment ratio (%) of Pre-primary schools in Cameroon to that in Ghana?
Your response must be concise. 0.29. What is the ratio of the Gross enrolment ratio (%) in Primary schools in Cameroon to that in Ghana?
Give a very brief answer. 1.67. What is the ratio of the Gross enrolment ratio (%) in Secondary schools in Cameroon to that in Ghana?
Provide a succinct answer. 0.71. What is the ratio of the Gross enrolment ratio (%) of Tertiary schools in Cameroon to that in Ghana?
Keep it short and to the point. 1.39. What is the ratio of the Gross enrolment ratio (%) of Pre-primary schools in Cameroon to that in Korea (Republic)?
Offer a very short reply. 0.37. What is the ratio of the Gross enrolment ratio (%) of Primary schools in Cameroon to that in Korea (Republic)?
Offer a terse response. 1.06. What is the ratio of the Gross enrolment ratio (%) of Secondary schools in Cameroon to that in Korea (Republic)?
Make the answer very short. 0.48. What is the ratio of the Gross enrolment ratio (%) of Tertiary schools in Cameroon to that in Korea (Republic)?
Keep it short and to the point. 19.88. What is the ratio of the Gross enrolment ratio (%) in Pre-primary schools in Cameroon to that in Micronesia?
Provide a succinct answer. 1.17. What is the ratio of the Gross enrolment ratio (%) in Primary schools in Cameroon to that in Micronesia?
Make the answer very short. 1.13. What is the ratio of the Gross enrolment ratio (%) in Secondary schools in Cameroon to that in Micronesia?
Give a very brief answer. 1.26. What is the ratio of the Gross enrolment ratio (%) of Tertiary schools in Cameroon to that in Micronesia?
Your response must be concise. 0.42. What is the ratio of the Gross enrolment ratio (%) in Pre-primary schools in Cameroon to that in Morocco?
Make the answer very short. 0.55. What is the ratio of the Gross enrolment ratio (%) of Primary schools in Cameroon to that in Morocco?
Keep it short and to the point. 1.18. What is the ratio of the Gross enrolment ratio (%) of Secondary schools in Cameroon to that in Morocco?
Keep it short and to the point. 0.71. What is the ratio of the Gross enrolment ratio (%) of Tertiary schools in Cameroon to that in Morocco?
Ensure brevity in your answer.  1.65. What is the ratio of the Gross enrolment ratio (%) of Pre-primary schools in Cameroon to that in Nepal?
Keep it short and to the point. 0.4. What is the ratio of the Gross enrolment ratio (%) of Primary schools in Cameroon to that in Nepal?
Your answer should be very brief. 1.16. What is the ratio of the Gross enrolment ratio (%) in Secondary schools in Cameroon to that in Nepal?
Your answer should be compact. 0.42. What is the ratio of the Gross enrolment ratio (%) of Tertiary schools in Cameroon to that in Nepal?
Provide a short and direct response. 5.05. What is the ratio of the Gross enrolment ratio (%) of Pre-primary schools in Ghana to that in Korea (Republic)?
Your answer should be very brief. 1.26. What is the ratio of the Gross enrolment ratio (%) of Primary schools in Ghana to that in Korea (Republic)?
Your answer should be very brief. 0.64. What is the ratio of the Gross enrolment ratio (%) of Secondary schools in Ghana to that in Korea (Republic)?
Provide a short and direct response. 0.68. What is the ratio of the Gross enrolment ratio (%) in Tertiary schools in Ghana to that in Korea (Republic)?
Offer a very short reply. 14.3. What is the ratio of the Gross enrolment ratio (%) in Pre-primary schools in Ghana to that in Micronesia?
Your response must be concise. 4. What is the ratio of the Gross enrolment ratio (%) of Primary schools in Ghana to that in Micronesia?
Give a very brief answer. 0.68. What is the ratio of the Gross enrolment ratio (%) of Secondary schools in Ghana to that in Micronesia?
Offer a very short reply. 1.77. What is the ratio of the Gross enrolment ratio (%) in Tertiary schools in Ghana to that in Micronesia?
Make the answer very short. 0.3. What is the ratio of the Gross enrolment ratio (%) of Pre-primary schools in Ghana to that in Morocco?
Provide a succinct answer. 1.88. What is the ratio of the Gross enrolment ratio (%) in Primary schools in Ghana to that in Morocco?
Provide a succinct answer. 0.71. What is the ratio of the Gross enrolment ratio (%) of Secondary schools in Ghana to that in Morocco?
Make the answer very short. 1. What is the ratio of the Gross enrolment ratio (%) in Tertiary schools in Ghana to that in Morocco?
Offer a very short reply. 1.19. What is the ratio of the Gross enrolment ratio (%) of Pre-primary schools in Ghana to that in Nepal?
Ensure brevity in your answer.  1.35. What is the ratio of the Gross enrolment ratio (%) of Primary schools in Ghana to that in Nepal?
Make the answer very short. 0.69. What is the ratio of the Gross enrolment ratio (%) in Secondary schools in Ghana to that in Nepal?
Make the answer very short. 0.59. What is the ratio of the Gross enrolment ratio (%) in Tertiary schools in Ghana to that in Nepal?
Provide a short and direct response. 3.64. What is the ratio of the Gross enrolment ratio (%) of Pre-primary schools in Korea (Republic) to that in Micronesia?
Offer a terse response. 3.17. What is the ratio of the Gross enrolment ratio (%) of Primary schools in Korea (Republic) to that in Micronesia?
Your answer should be compact. 1.06. What is the ratio of the Gross enrolment ratio (%) in Secondary schools in Korea (Republic) to that in Micronesia?
Your response must be concise. 2.61. What is the ratio of the Gross enrolment ratio (%) in Tertiary schools in Korea (Republic) to that in Micronesia?
Make the answer very short. 0.02. What is the ratio of the Gross enrolment ratio (%) in Pre-primary schools in Korea (Republic) to that in Morocco?
Offer a terse response. 1.49. What is the ratio of the Gross enrolment ratio (%) in Primary schools in Korea (Republic) to that in Morocco?
Make the answer very short. 1.12. What is the ratio of the Gross enrolment ratio (%) in Secondary schools in Korea (Republic) to that in Morocco?
Your answer should be very brief. 1.48. What is the ratio of the Gross enrolment ratio (%) in Tertiary schools in Korea (Republic) to that in Morocco?
Your response must be concise. 0.08. What is the ratio of the Gross enrolment ratio (%) in Pre-primary schools in Korea (Republic) to that in Nepal?
Provide a succinct answer. 1.07. What is the ratio of the Gross enrolment ratio (%) in Primary schools in Korea (Republic) to that in Nepal?
Make the answer very short. 1.09. What is the ratio of the Gross enrolment ratio (%) of Secondary schools in Korea (Republic) to that in Nepal?
Offer a very short reply. 0.87. What is the ratio of the Gross enrolment ratio (%) of Tertiary schools in Korea (Republic) to that in Nepal?
Your response must be concise. 0.25. What is the ratio of the Gross enrolment ratio (%) in Pre-primary schools in Micronesia to that in Morocco?
Provide a short and direct response. 0.47. What is the ratio of the Gross enrolment ratio (%) of Primary schools in Micronesia to that in Morocco?
Your response must be concise. 1.05. What is the ratio of the Gross enrolment ratio (%) of Secondary schools in Micronesia to that in Morocco?
Give a very brief answer. 0.57. What is the ratio of the Gross enrolment ratio (%) in Tertiary schools in Micronesia to that in Morocco?
Ensure brevity in your answer.  3.95. What is the ratio of the Gross enrolment ratio (%) of Pre-primary schools in Micronesia to that in Nepal?
Offer a terse response. 0.34. What is the ratio of the Gross enrolment ratio (%) in Primary schools in Micronesia to that in Nepal?
Provide a short and direct response. 1.03. What is the ratio of the Gross enrolment ratio (%) of Secondary schools in Micronesia to that in Nepal?
Make the answer very short. 0.33. What is the ratio of the Gross enrolment ratio (%) in Tertiary schools in Micronesia to that in Nepal?
Your answer should be very brief. 12.09. What is the ratio of the Gross enrolment ratio (%) of Pre-primary schools in Morocco to that in Nepal?
Offer a terse response. 0.72. What is the ratio of the Gross enrolment ratio (%) of Primary schools in Morocco to that in Nepal?
Provide a short and direct response. 0.98. What is the ratio of the Gross enrolment ratio (%) in Secondary schools in Morocco to that in Nepal?
Your answer should be compact. 0.59. What is the ratio of the Gross enrolment ratio (%) in Tertiary schools in Morocco to that in Nepal?
Make the answer very short. 3.06. What is the difference between the highest and the second highest Gross enrolment ratio (%) in Pre-primary schools?
Your answer should be very brief. 24.2. What is the difference between the highest and the second highest Gross enrolment ratio (%) of Primary schools?
Keep it short and to the point. 6.47. What is the difference between the highest and the second highest Gross enrolment ratio (%) in Secondary schools?
Your response must be concise. 14.58. What is the difference between the highest and the second highest Gross enrolment ratio (%) of Tertiary schools?
Your answer should be compact. 56.22. What is the difference between the highest and the lowest Gross enrolment ratio (%) in Pre-primary schools?
Your answer should be compact. 87.65. What is the difference between the highest and the lowest Gross enrolment ratio (%) of Primary schools?
Your response must be concise. 45.42. What is the difference between the highest and the lowest Gross enrolment ratio (%) of Secondary schools?
Keep it short and to the point. 75.72. What is the difference between the highest and the lowest Gross enrolment ratio (%) in Tertiary schools?
Offer a very short reply. 94.55. 